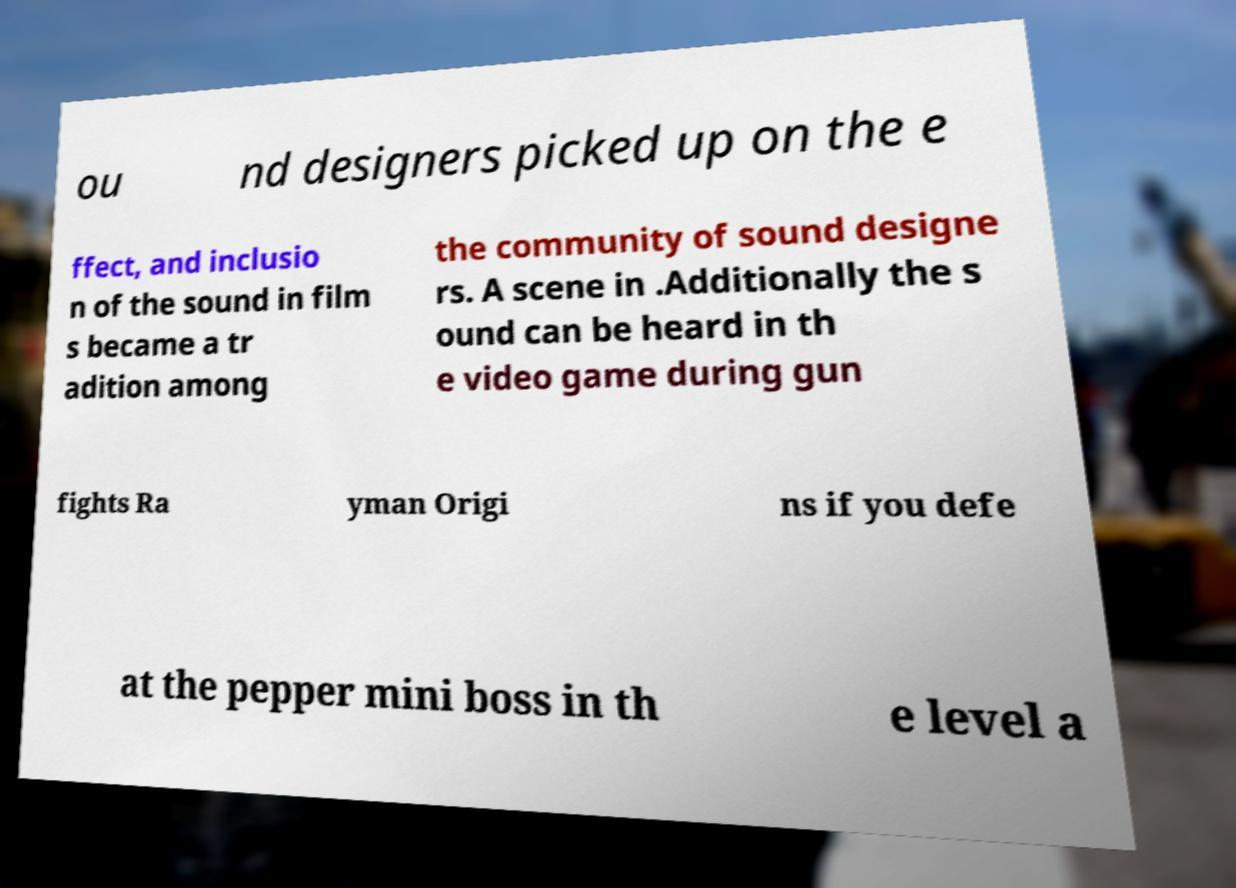I need the written content from this picture converted into text. Can you do that? ou nd designers picked up on the e ffect, and inclusio n of the sound in film s became a tr adition among the community of sound designe rs. A scene in .Additionally the s ound can be heard in th e video game during gun fights Ra yman Origi ns if you defe at the pepper mini boss in th e level a 